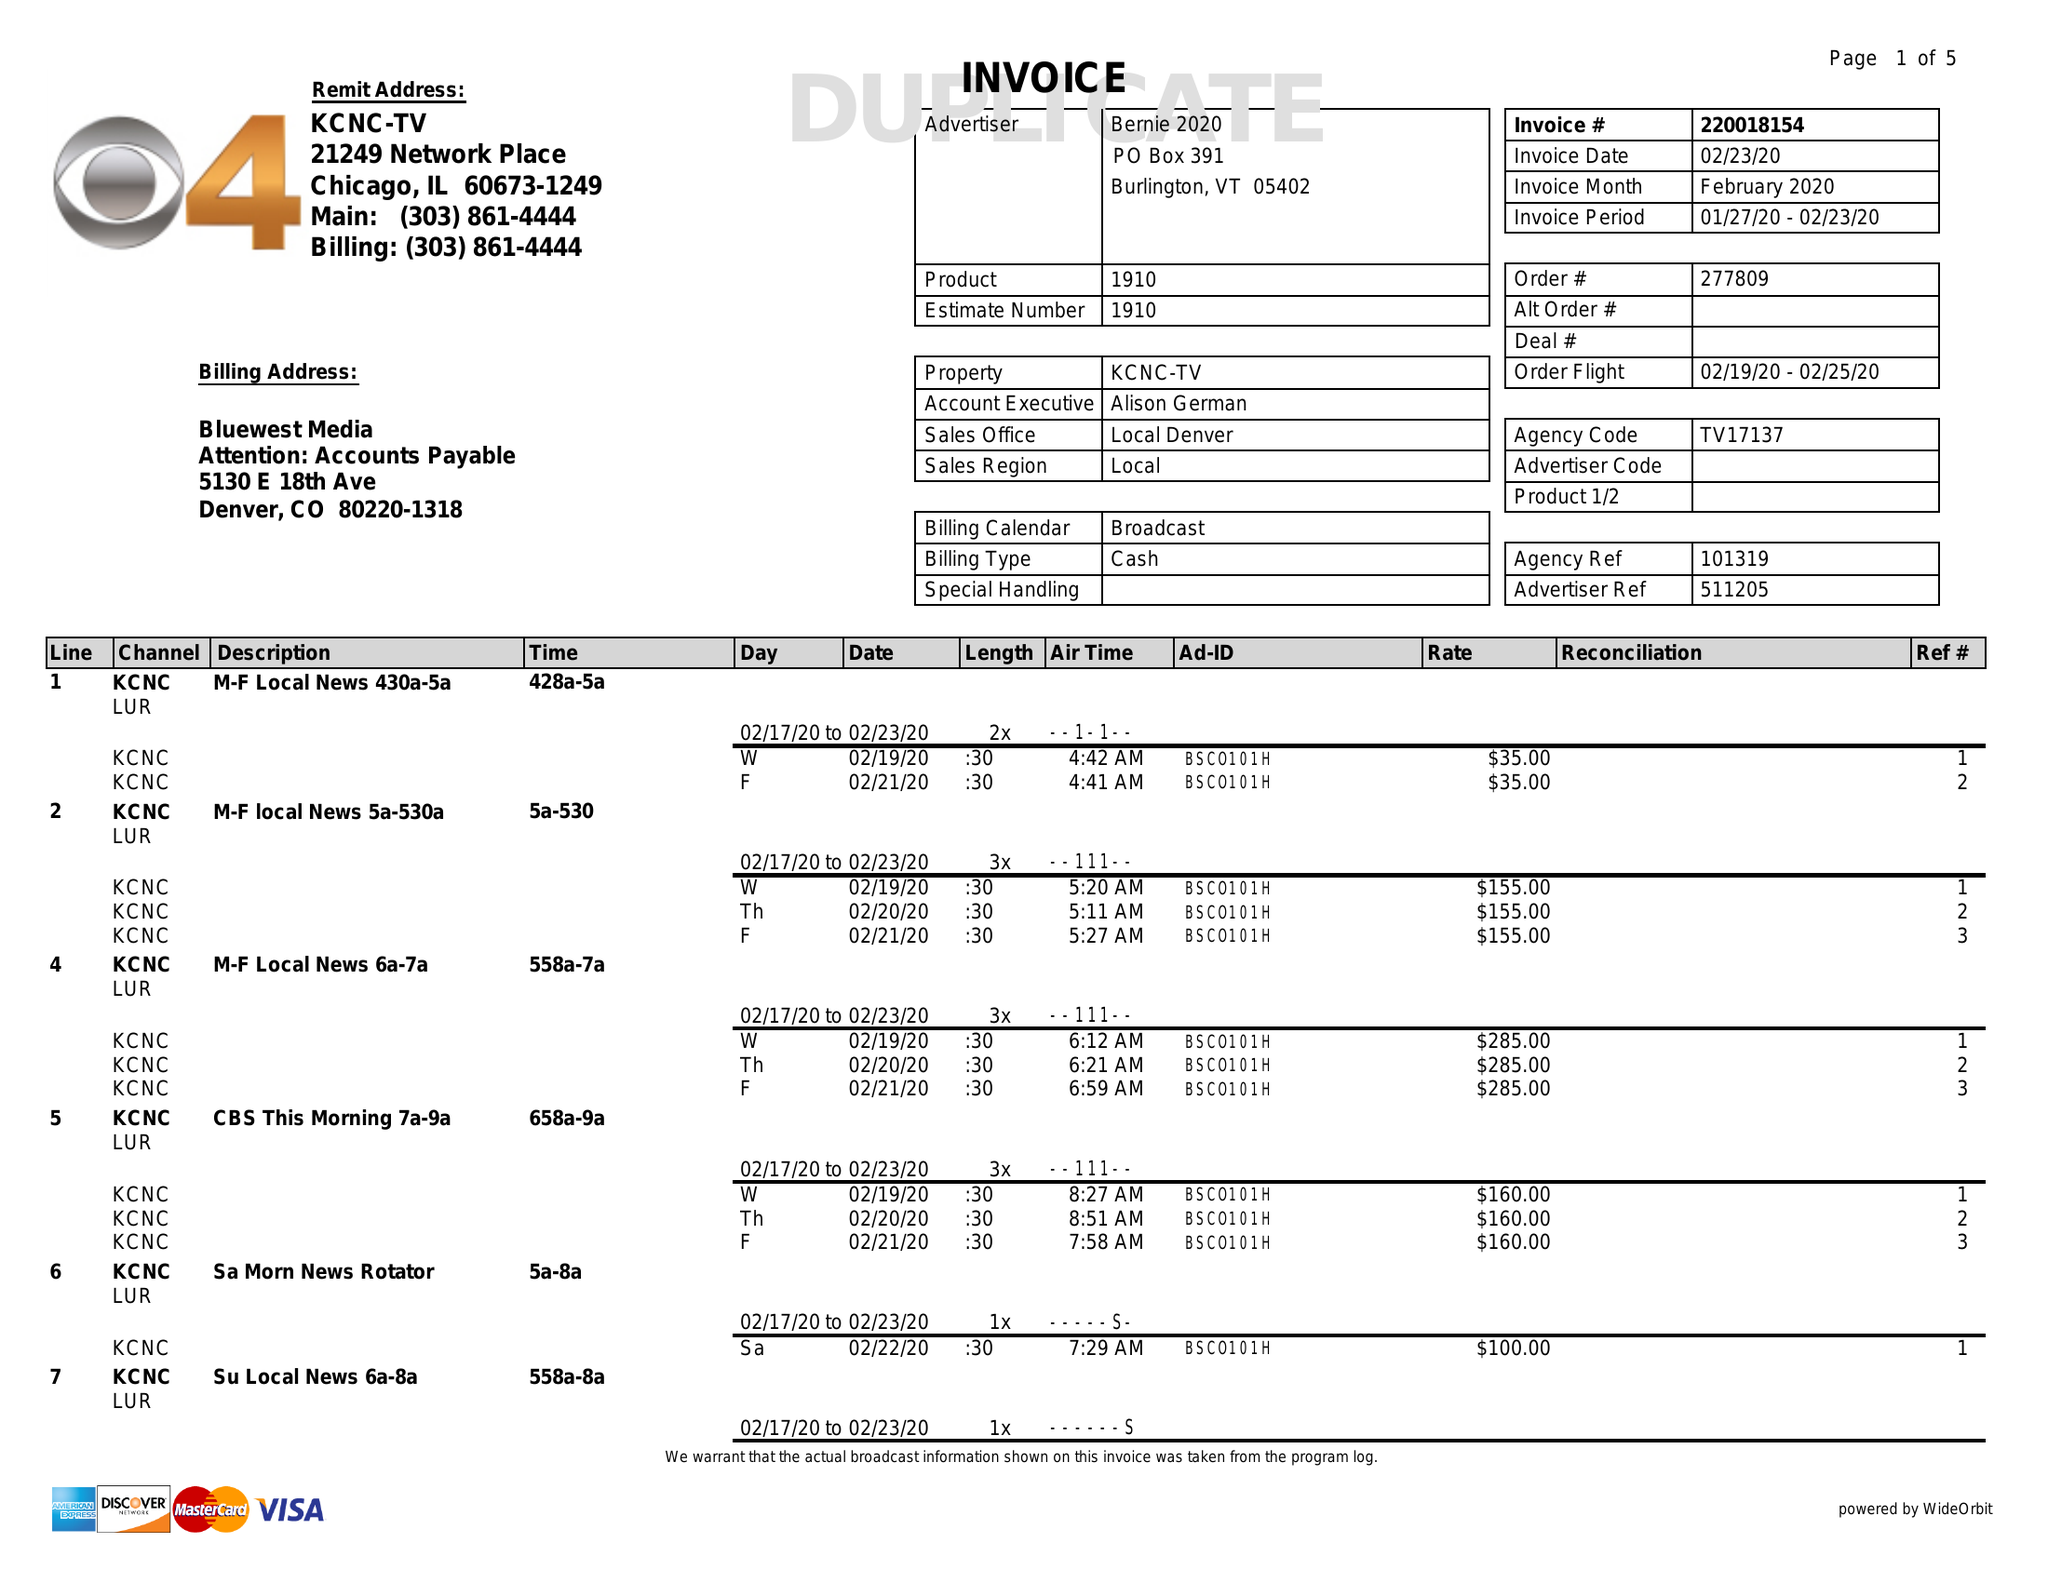What is the value for the flight_from?
Answer the question using a single word or phrase. 02/19/20 